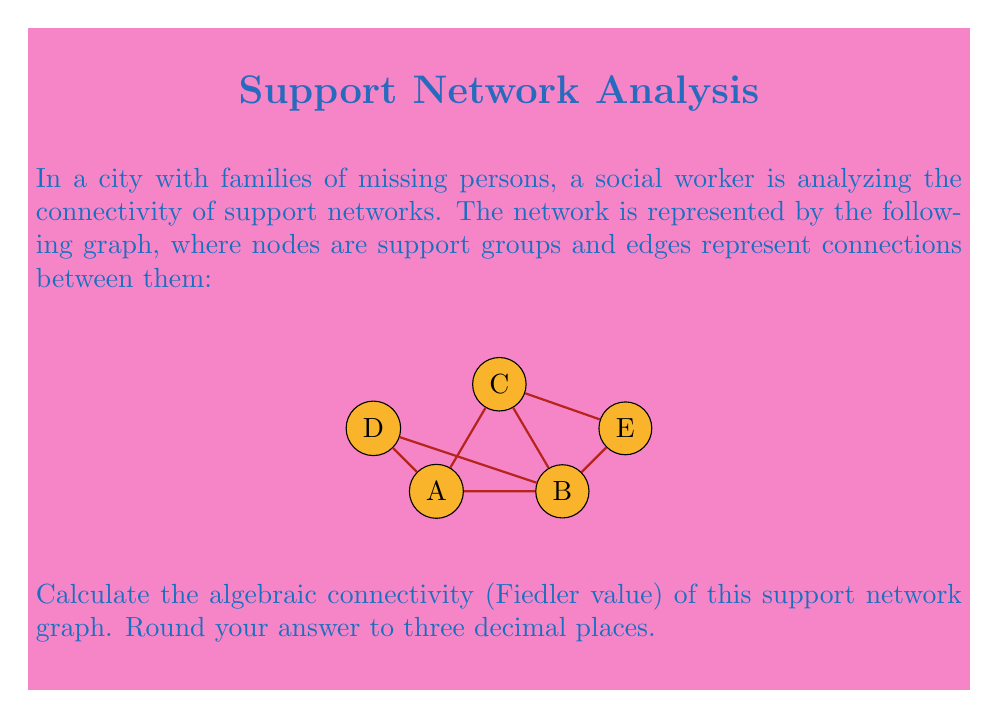Could you help me with this problem? To find the algebraic connectivity of the graph, we need to follow these steps:

1) First, construct the adjacency matrix $A$ of the graph:

   $$A = \begin{bmatrix}
   0 & 1 & 1 & 1 & 0 \\
   1 & 0 & 1 & 1 & 1 \\
   1 & 1 & 0 & 0 & 1 \\
   1 & 1 & 0 & 0 & 0 \\
   0 & 1 & 1 & 0 & 0
   \end{bmatrix}$$

2) Calculate the degree matrix $D$:

   $$D = \begin{bmatrix}
   3 & 0 & 0 & 0 & 0 \\
   0 & 4 & 0 & 0 & 0 \\
   0 & 0 & 3 & 0 & 0 \\
   0 & 0 & 0 & 2 & 0 \\
   0 & 0 & 0 & 0 & 2
   \end{bmatrix}$$

3) Compute the Laplacian matrix $L = D - A$:

   $$L = \begin{bmatrix}
   3 & -1 & -1 & -1 & 0 \\
   -1 & 4 & -1 & -1 & -1 \\
   -1 & -1 & 3 & 0 & -1 \\
   -1 & -1 & 0 & 2 & 0 \\
   0 & -1 & -1 & 0 & 2
   \end{bmatrix}$$

4) Find the eigenvalues of $L$. Using a computer algebra system or numerical methods, we get:

   $\lambda_1 = 0$
   $\lambda_2 \approx 0.7639$
   $\lambda_3 \approx 2.0000$
   $\lambda_4 \approx 3.2361$
   $\lambda_5 \approx 5.0000$

5) The algebraic connectivity (Fiedler value) is the second smallest eigenvalue, which is $\lambda_2 \approx 0.7639$.

6) Rounding to three decimal places, we get 0.764.

The Fiedler value provides information about the overall connectivity of the graph. A higher value indicates better connectivity and robustness of the network.
Answer: 0.764 